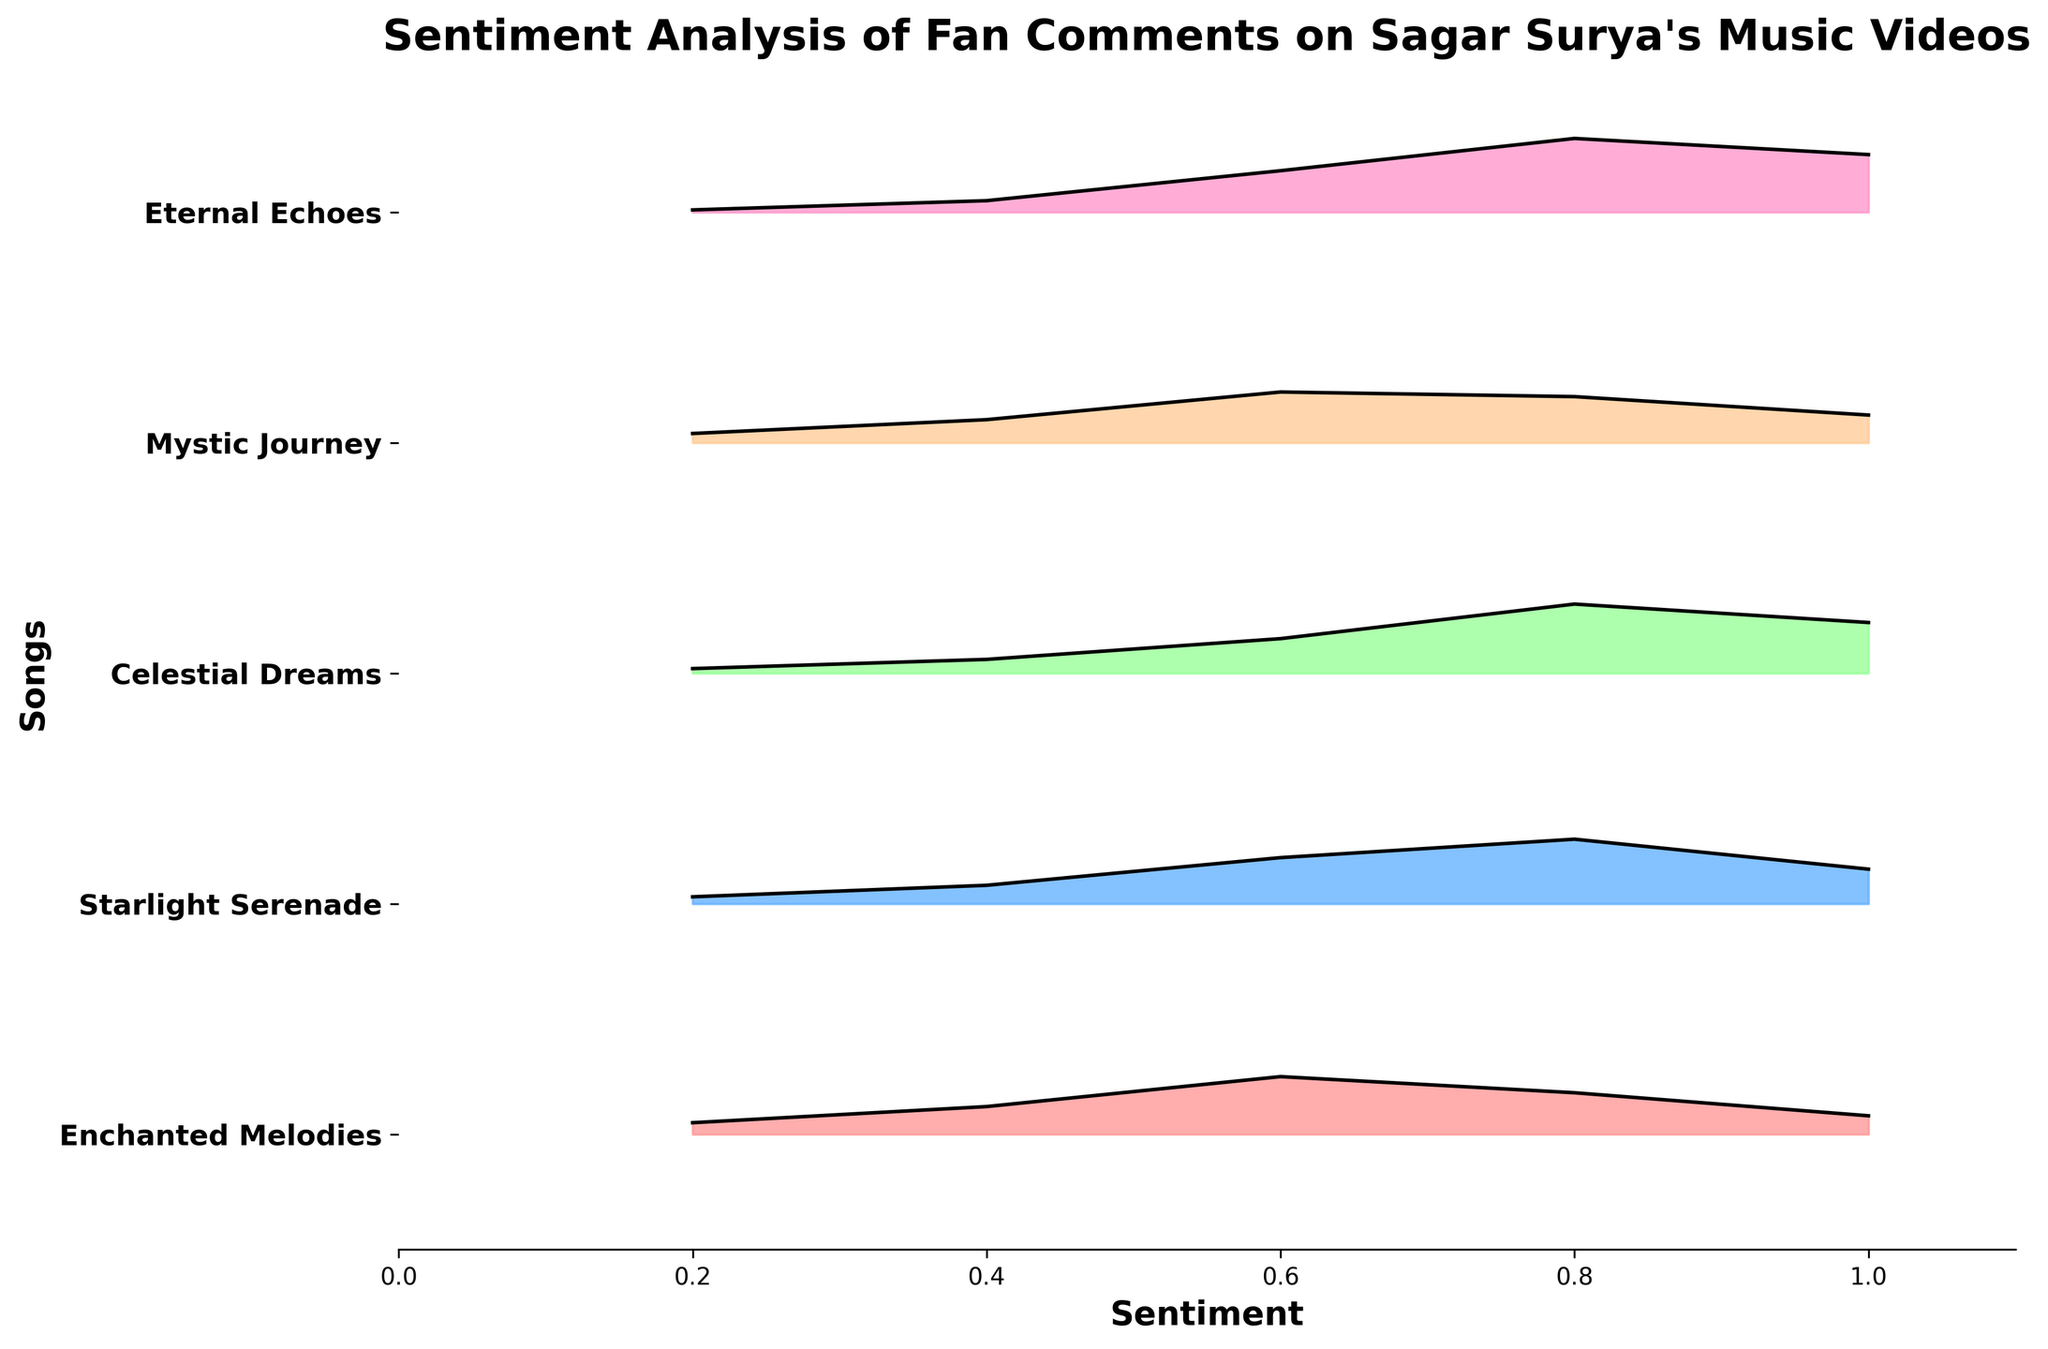What is the title of the figure? The title of the figure is usually displayed at the top and provides a brief description of what the figure represents. Here, the title is "Sentiment Analysis of Fan Comments on Sagar Surya's Music Videos"
Answer: Sentiment Analysis of Fan Comments on Sagar Surya's Music Videos How many songs are represented in the figure? Count the unique entries on the vertical axis (y-axis), which lists each song. Here, there are five songs listed.
Answer: Five Which song has the highest density of positive sentiment (near sentiment value 1.0)? To determine which song has the highest density at a sentiment value near 1.0, compare the densities at the 1.0 sentiment point for each song. "Eternal Echoes" has the highest density value of 0.25 at sentiment 1.0
Answer: Eternal Echoes What is the x-axis label of the figure? The x-axis label describes what the x-axis represents. In this figure, the x-axis is labeled "Sentiment"
Answer: Sentiment Which song shows the most widespread distribution of sentiment values? To identify the song with the most widespread sentiment distribution, look for the one with significant densities spread across multiple sentiment values. "Eternal Echoes" has noticeable densities spanning the entire range of sentiment values from 0.2 to 1.0.
Answer: Eternal Echoes For the song "Mystic Journey," at which sentiment value does the density peak? Check the density values for "Mystic Journey" across different sentiment values. The density peaks at sentiment value 0.6 with a density of 0.22
Answer: 0.6 What is the density of "Starlight Serenade" at sentiment 0.8? To find this, trace the sentiment value of 0.8 for "Starlight Serenade" and note the corresponding density. The density at this point is 0.28
Answer: 0.28 Compare the density of "Celestial Dreams" and "Mystic Journey" at sentiment 0.4. Which one is higher? Compare the given density values at sentiment 0.4 for both songs. "Mystic Journey" has a density of 0.10, while "Celestial Dreams" has a density of 0.06. Thus, "Mystic Journey" has a higher density.
Answer: Mystic Journey Which song has the lowest density at sentiment 0.2? Compare the density values at sentiment 0.2 for all songs. "Eternal Echoes" has the lowest density of 0.01 at sentiment 0.2
Answer: Eternal Echoes 